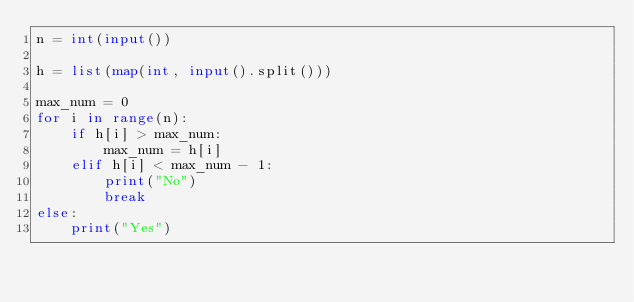<code> <loc_0><loc_0><loc_500><loc_500><_Python_>n = int(input())

h = list(map(int, input().split()))

max_num = 0
for i in range(n):
    if h[i] > max_num:
        max_num = h[i]
    elif h[i] < max_num - 1:
        print("No")
        break
else:
    print("Yes")</code> 